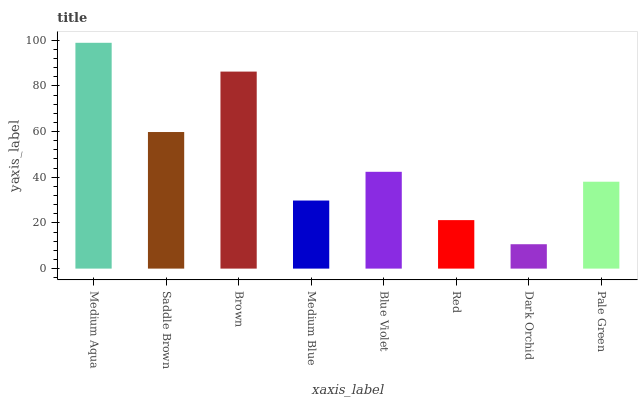Is Saddle Brown the minimum?
Answer yes or no. No. Is Saddle Brown the maximum?
Answer yes or no. No. Is Medium Aqua greater than Saddle Brown?
Answer yes or no. Yes. Is Saddle Brown less than Medium Aqua?
Answer yes or no. Yes. Is Saddle Brown greater than Medium Aqua?
Answer yes or no. No. Is Medium Aqua less than Saddle Brown?
Answer yes or no. No. Is Blue Violet the high median?
Answer yes or no. Yes. Is Pale Green the low median?
Answer yes or no. Yes. Is Red the high median?
Answer yes or no. No. Is Red the low median?
Answer yes or no. No. 